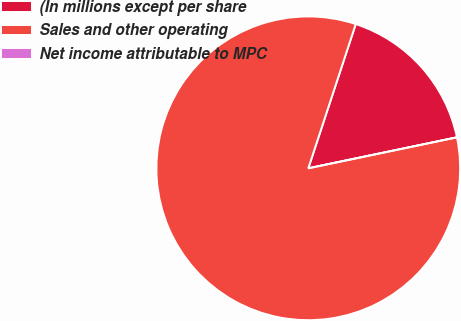Convert chart to OTSL. <chart><loc_0><loc_0><loc_500><loc_500><pie_chart><fcel>(In millions except per share<fcel>Sales and other operating<fcel>Net income attributable to MPC<nl><fcel>16.67%<fcel>83.33%<fcel>0.0%<nl></chart> 